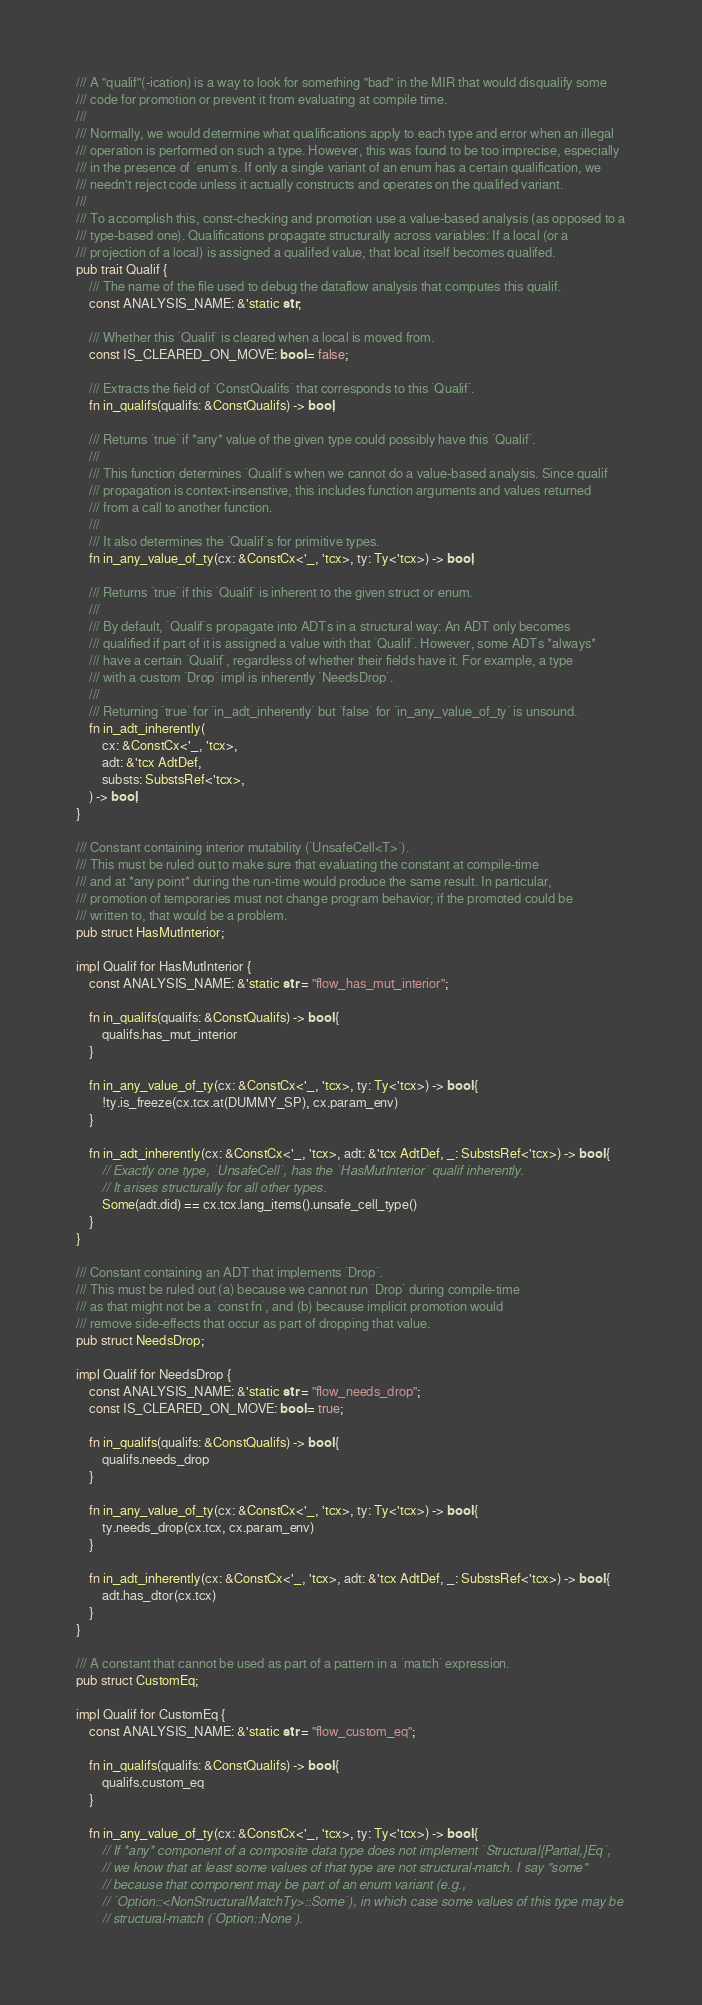Convert code to text. <code><loc_0><loc_0><loc_500><loc_500><_Rust_>/// A "qualif"(-ication) is a way to look for something "bad" in the MIR that would disqualify some
/// code for promotion or prevent it from evaluating at compile time.
///
/// Normally, we would determine what qualifications apply to each type and error when an illegal
/// operation is performed on such a type. However, this was found to be too imprecise, especially
/// in the presence of `enum`s. If only a single variant of an enum has a certain qualification, we
/// needn't reject code unless it actually constructs and operates on the qualifed variant.
///
/// To accomplish this, const-checking and promotion use a value-based analysis (as opposed to a
/// type-based one). Qualifications propagate structurally across variables: If a local (or a
/// projection of a local) is assigned a qualifed value, that local itself becomes qualifed.
pub trait Qualif {
    /// The name of the file used to debug the dataflow analysis that computes this qualif.
    const ANALYSIS_NAME: &'static str;

    /// Whether this `Qualif` is cleared when a local is moved from.
    const IS_CLEARED_ON_MOVE: bool = false;

    /// Extracts the field of `ConstQualifs` that corresponds to this `Qualif`.
    fn in_qualifs(qualifs: &ConstQualifs) -> bool;

    /// Returns `true` if *any* value of the given type could possibly have this `Qualif`.
    ///
    /// This function determines `Qualif`s when we cannot do a value-based analysis. Since qualif
    /// propagation is context-insenstive, this includes function arguments and values returned
    /// from a call to another function.
    ///
    /// It also determines the `Qualif`s for primitive types.
    fn in_any_value_of_ty(cx: &ConstCx<'_, 'tcx>, ty: Ty<'tcx>) -> bool;

    /// Returns `true` if this `Qualif` is inherent to the given struct or enum.
    ///
    /// By default, `Qualif`s propagate into ADTs in a structural way: An ADT only becomes
    /// qualified if part of it is assigned a value with that `Qualif`. However, some ADTs *always*
    /// have a certain `Qualif`, regardless of whether their fields have it. For example, a type
    /// with a custom `Drop` impl is inherently `NeedsDrop`.
    ///
    /// Returning `true` for `in_adt_inherently` but `false` for `in_any_value_of_ty` is unsound.
    fn in_adt_inherently(
        cx: &ConstCx<'_, 'tcx>,
        adt: &'tcx AdtDef,
        substs: SubstsRef<'tcx>,
    ) -> bool;
}

/// Constant containing interior mutability (`UnsafeCell<T>`).
/// This must be ruled out to make sure that evaluating the constant at compile-time
/// and at *any point* during the run-time would produce the same result. In particular,
/// promotion of temporaries must not change program behavior; if the promoted could be
/// written to, that would be a problem.
pub struct HasMutInterior;

impl Qualif for HasMutInterior {
    const ANALYSIS_NAME: &'static str = "flow_has_mut_interior";

    fn in_qualifs(qualifs: &ConstQualifs) -> bool {
        qualifs.has_mut_interior
    }

    fn in_any_value_of_ty(cx: &ConstCx<'_, 'tcx>, ty: Ty<'tcx>) -> bool {
        !ty.is_freeze(cx.tcx.at(DUMMY_SP), cx.param_env)
    }

    fn in_adt_inherently(cx: &ConstCx<'_, 'tcx>, adt: &'tcx AdtDef, _: SubstsRef<'tcx>) -> bool {
        // Exactly one type, `UnsafeCell`, has the `HasMutInterior` qualif inherently.
        // It arises structurally for all other types.
        Some(adt.did) == cx.tcx.lang_items().unsafe_cell_type()
    }
}

/// Constant containing an ADT that implements `Drop`.
/// This must be ruled out (a) because we cannot run `Drop` during compile-time
/// as that might not be a `const fn`, and (b) because implicit promotion would
/// remove side-effects that occur as part of dropping that value.
pub struct NeedsDrop;

impl Qualif for NeedsDrop {
    const ANALYSIS_NAME: &'static str = "flow_needs_drop";
    const IS_CLEARED_ON_MOVE: bool = true;

    fn in_qualifs(qualifs: &ConstQualifs) -> bool {
        qualifs.needs_drop
    }

    fn in_any_value_of_ty(cx: &ConstCx<'_, 'tcx>, ty: Ty<'tcx>) -> bool {
        ty.needs_drop(cx.tcx, cx.param_env)
    }

    fn in_adt_inherently(cx: &ConstCx<'_, 'tcx>, adt: &'tcx AdtDef, _: SubstsRef<'tcx>) -> bool {
        adt.has_dtor(cx.tcx)
    }
}

/// A constant that cannot be used as part of a pattern in a `match` expression.
pub struct CustomEq;

impl Qualif for CustomEq {
    const ANALYSIS_NAME: &'static str = "flow_custom_eq";

    fn in_qualifs(qualifs: &ConstQualifs) -> bool {
        qualifs.custom_eq
    }

    fn in_any_value_of_ty(cx: &ConstCx<'_, 'tcx>, ty: Ty<'tcx>) -> bool {
        // If *any* component of a composite data type does not implement `Structural{Partial,}Eq`,
        // we know that at least some values of that type are not structural-match. I say "some"
        // because that component may be part of an enum variant (e.g.,
        // `Option::<NonStructuralMatchTy>::Some`), in which case some values of this type may be
        // structural-match (`Option::None`).</code> 